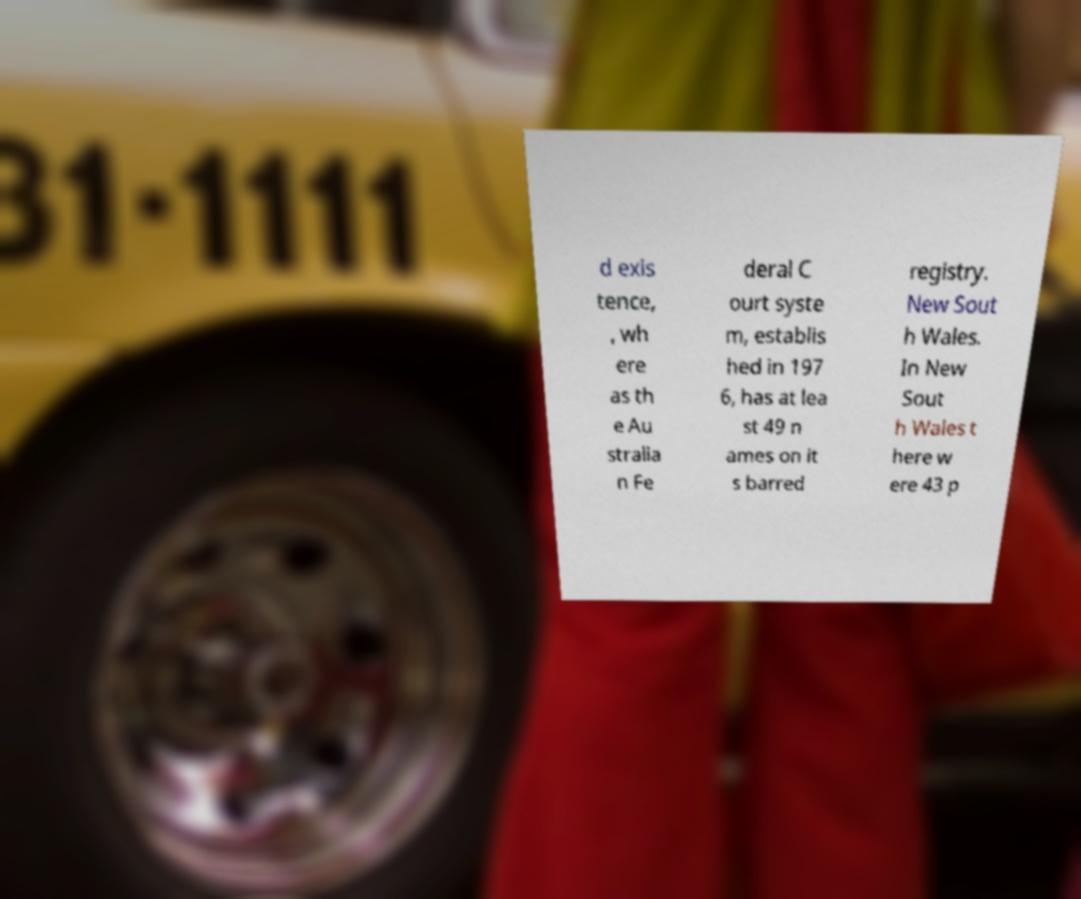Please read and relay the text visible in this image. What does it say? d exis tence, , wh ere as th e Au stralia n Fe deral C ourt syste m, establis hed in 197 6, has at lea st 49 n ames on it s barred registry. New Sout h Wales. In New Sout h Wales t here w ere 43 p 